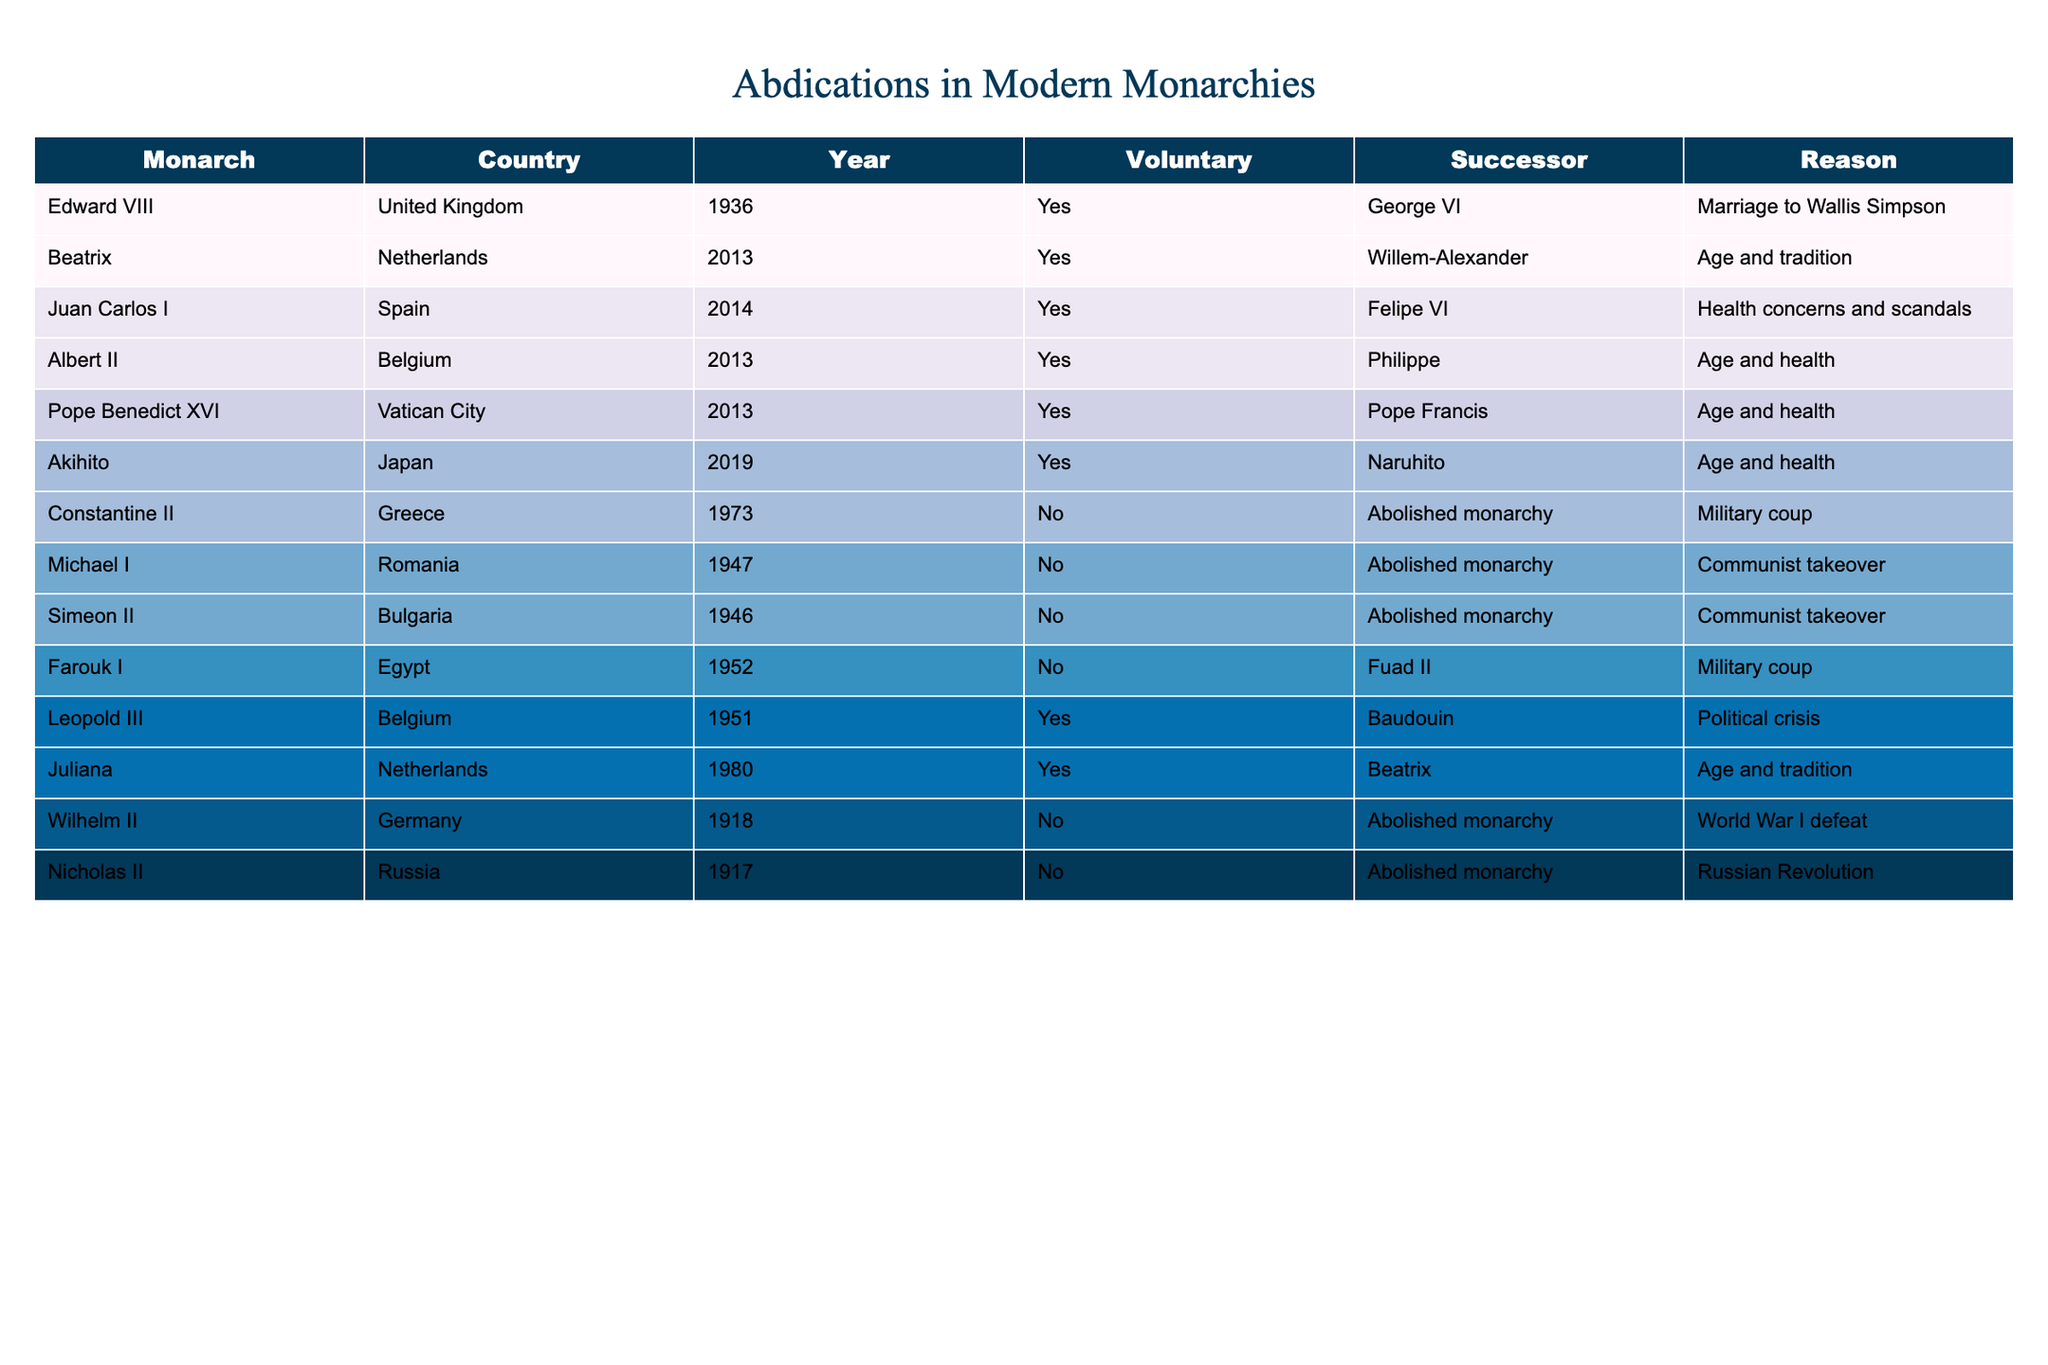What year did Edward VIII abdicate? The table lists the abdication of Edward VIII under the "Year" column in the corresponding row. This shows that he abdicated in 1936.
Answer: 1936 How many monarchs abdicated voluntarily? By reviewing the "Voluntary" column, we can count the instances marked "Yes". There are 6 instances of voluntary abdications: Edward VIII, Beatrix, Juan Carlos I, Albert II, Leopold III, and Juliana.
Answer: 6 Was the abdication of Juan Carlos I voluntary? Checking the "Voluntary" column in Juan Carlos I's row shows "Yes", indicating that his abdication was indeed voluntary.
Answer: Yes Which monarch abdicated due to health concerns and scandals? Examining the "Reason" column for each row reveals that Juan Carlos I abdicated due to health concerns and scandals, making him the correct answer.
Answer: Juan Carlos I What is the average year of abdication for the monarchs listed in the table? To find the average, sum the abdication years: 1936 + 2013 + 2014 + 2013 + 2013 + 2019 + 1973 + 1947 + 1946 + 1952 + 1951 + 1980 + 1918 + 1917 = 20513. Then divide by the number of abdications (14), resulting in 20513 / 14 = 1465.21, which has to be rounded down to 1465. The average year of the modern abdications is approximately 1950.
Answer: Around 1950 Did any monarchs abdicate after 2000? To answer this question, we check the "Year" column for any numbers greater than 2000. The table shows that several abdications occurred after 2000 (2013 and 2014).
Answer: Yes Which countries had monarchs that abdicated due to a political crisis? Looking at the "Reason" column, only Leopold III's abdication is associated with a political crisis. Hence, Belgium is the only country listed that fits this criteria.
Answer: Belgium What is the difference in years between the abdications of Edward VIII and Akihito? To find the difference, we subtract the abdication year of Akihito (2019) from Edward VIII (1936), resulting in 2019 - 1936 = 83 years. The difference in abdication years is 83.
Answer: 83 years What percentage of the monarchs listed abdicated voluntarily? There are a total of 14 listed abdications, and 6 of them are voluntary. To find the percentage, we calculate (6 / 14) * 100, which equals approximately 42.86%. Therefore, about 43% of the monarchs abdicated voluntarily.
Answer: Approximately 43% 